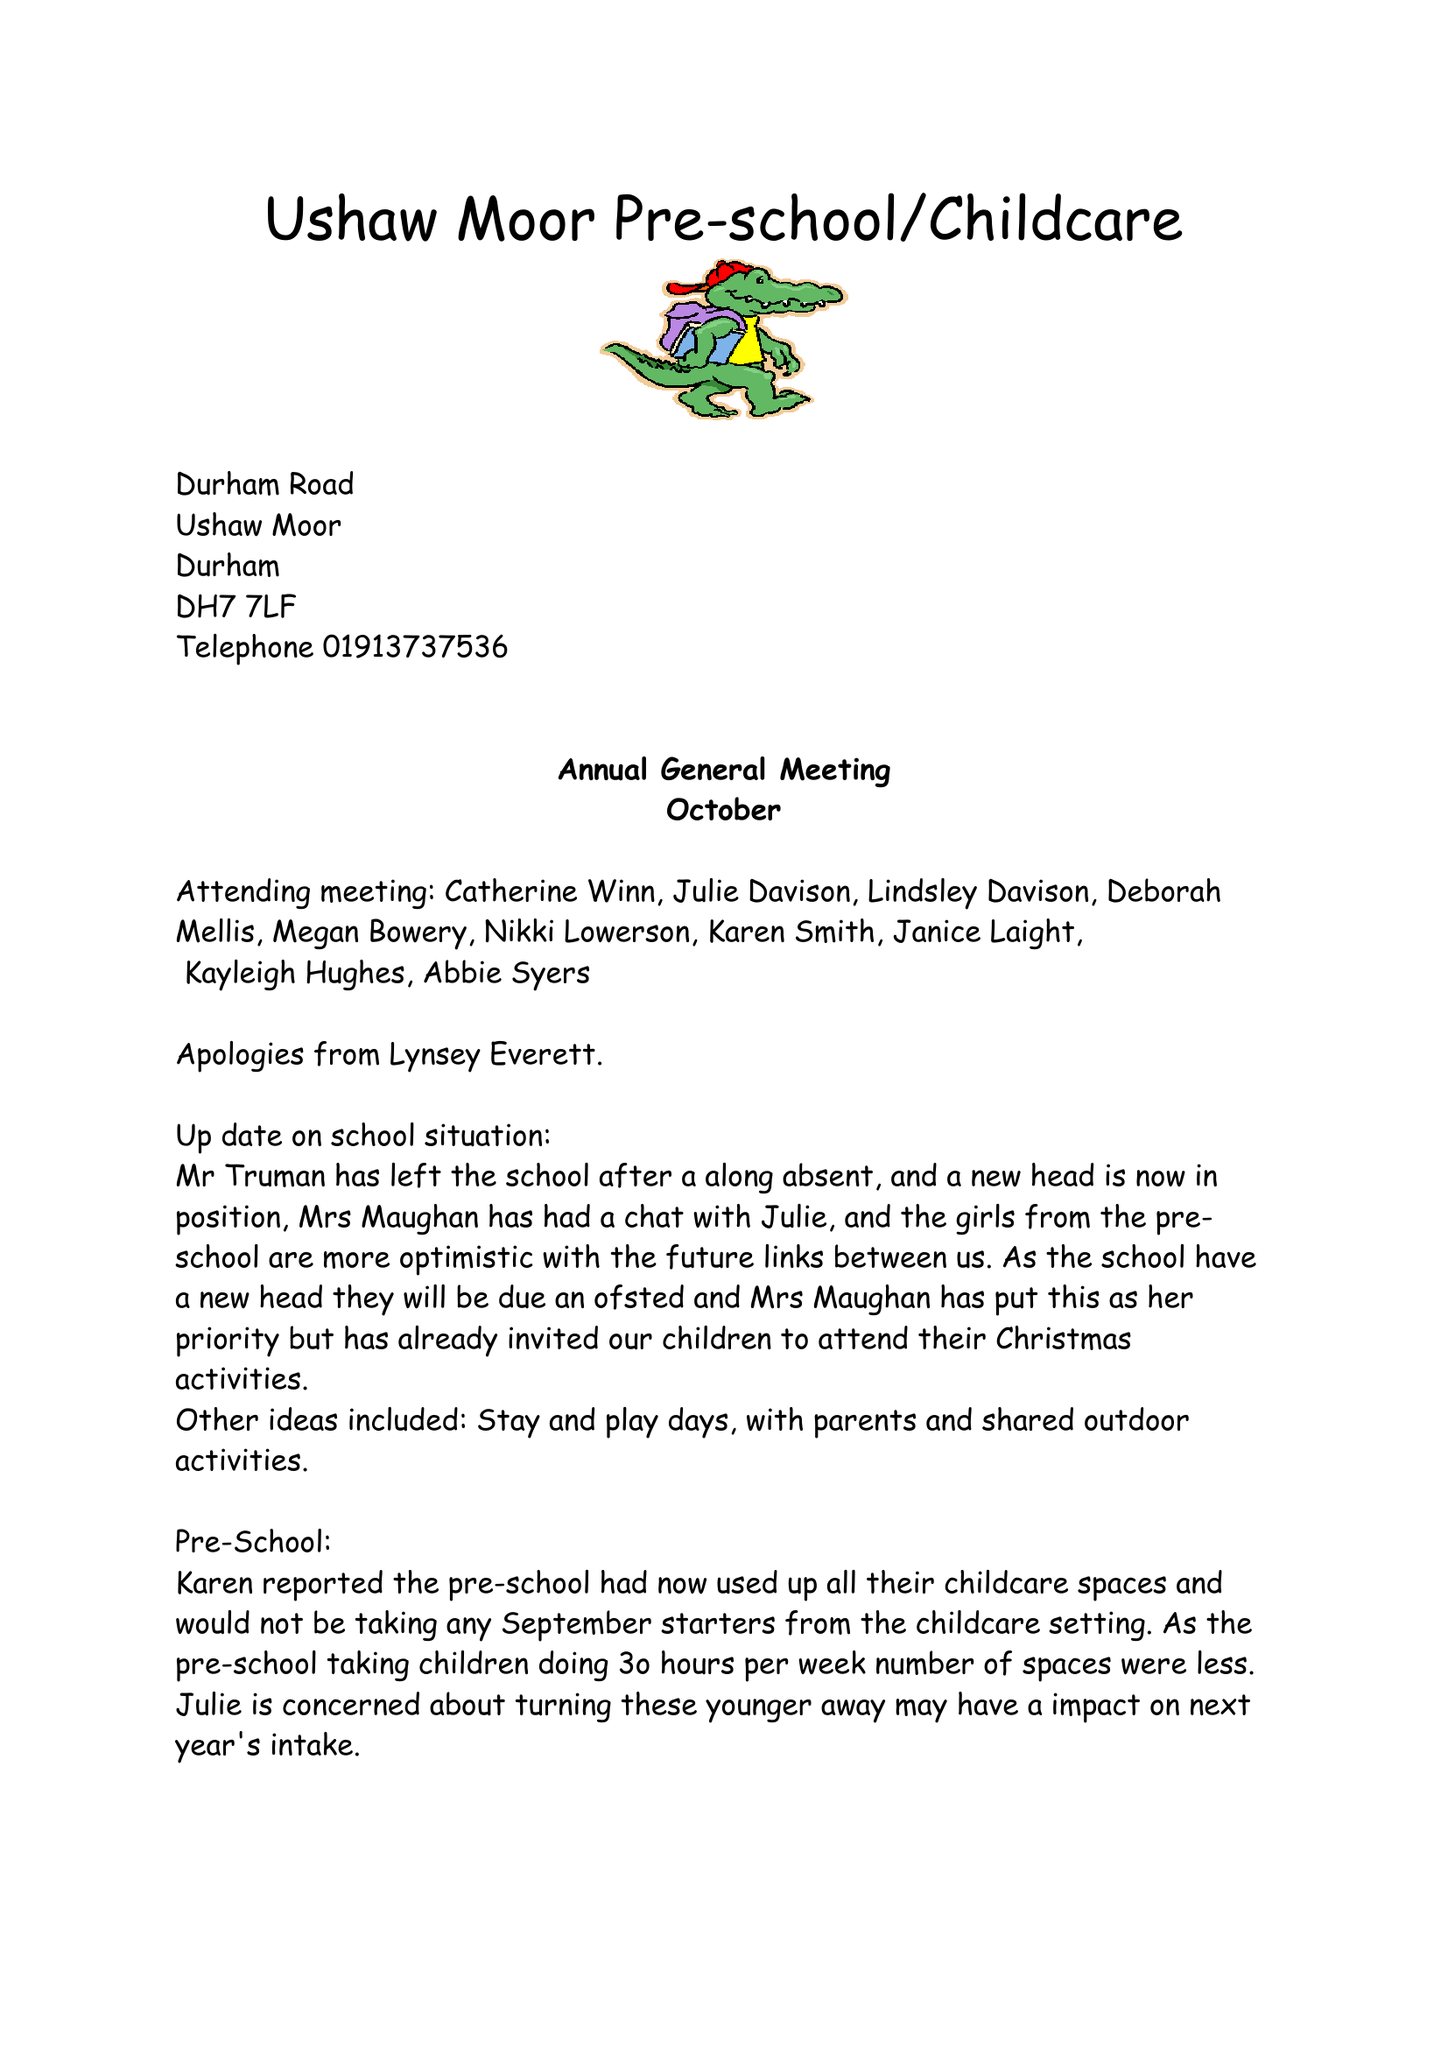What is the value for the spending_annually_in_british_pounds?
Answer the question using a single word or phrase. 189280.00 